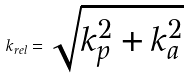Convert formula to latex. <formula><loc_0><loc_0><loc_500><loc_500>k _ { r e l } = \sqrt { k _ { p } ^ { 2 } + k _ { a } ^ { 2 } }</formula> 